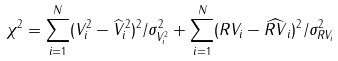<formula> <loc_0><loc_0><loc_500><loc_500>\chi ^ { 2 } = \sum _ { i = 1 } ^ { N } ( V _ { i } ^ { 2 } - \widehat { V } _ { i } ^ { 2 } ) ^ { 2 } / \sigma _ { V ^ { 2 } _ { i } } ^ { 2 } + \sum _ { i = 1 } ^ { N } ( R V _ { i } - \widehat { R V } _ { i } ) ^ { 2 } / \sigma _ { R V _ { i } } ^ { 2 }</formula> 